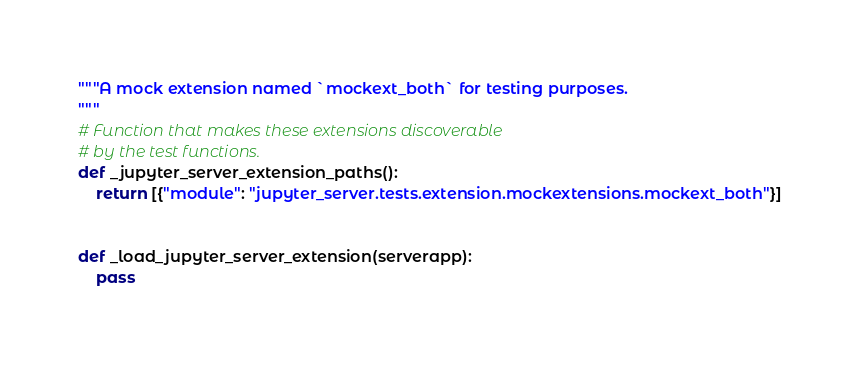<code> <loc_0><loc_0><loc_500><loc_500><_Python_>"""A mock extension named `mockext_both` for testing purposes.
"""
# Function that makes these extensions discoverable
# by the test functions.
def _jupyter_server_extension_paths():
    return [{"module": "jupyter_server.tests.extension.mockextensions.mockext_both"}]


def _load_jupyter_server_extension(serverapp):
    pass
</code> 